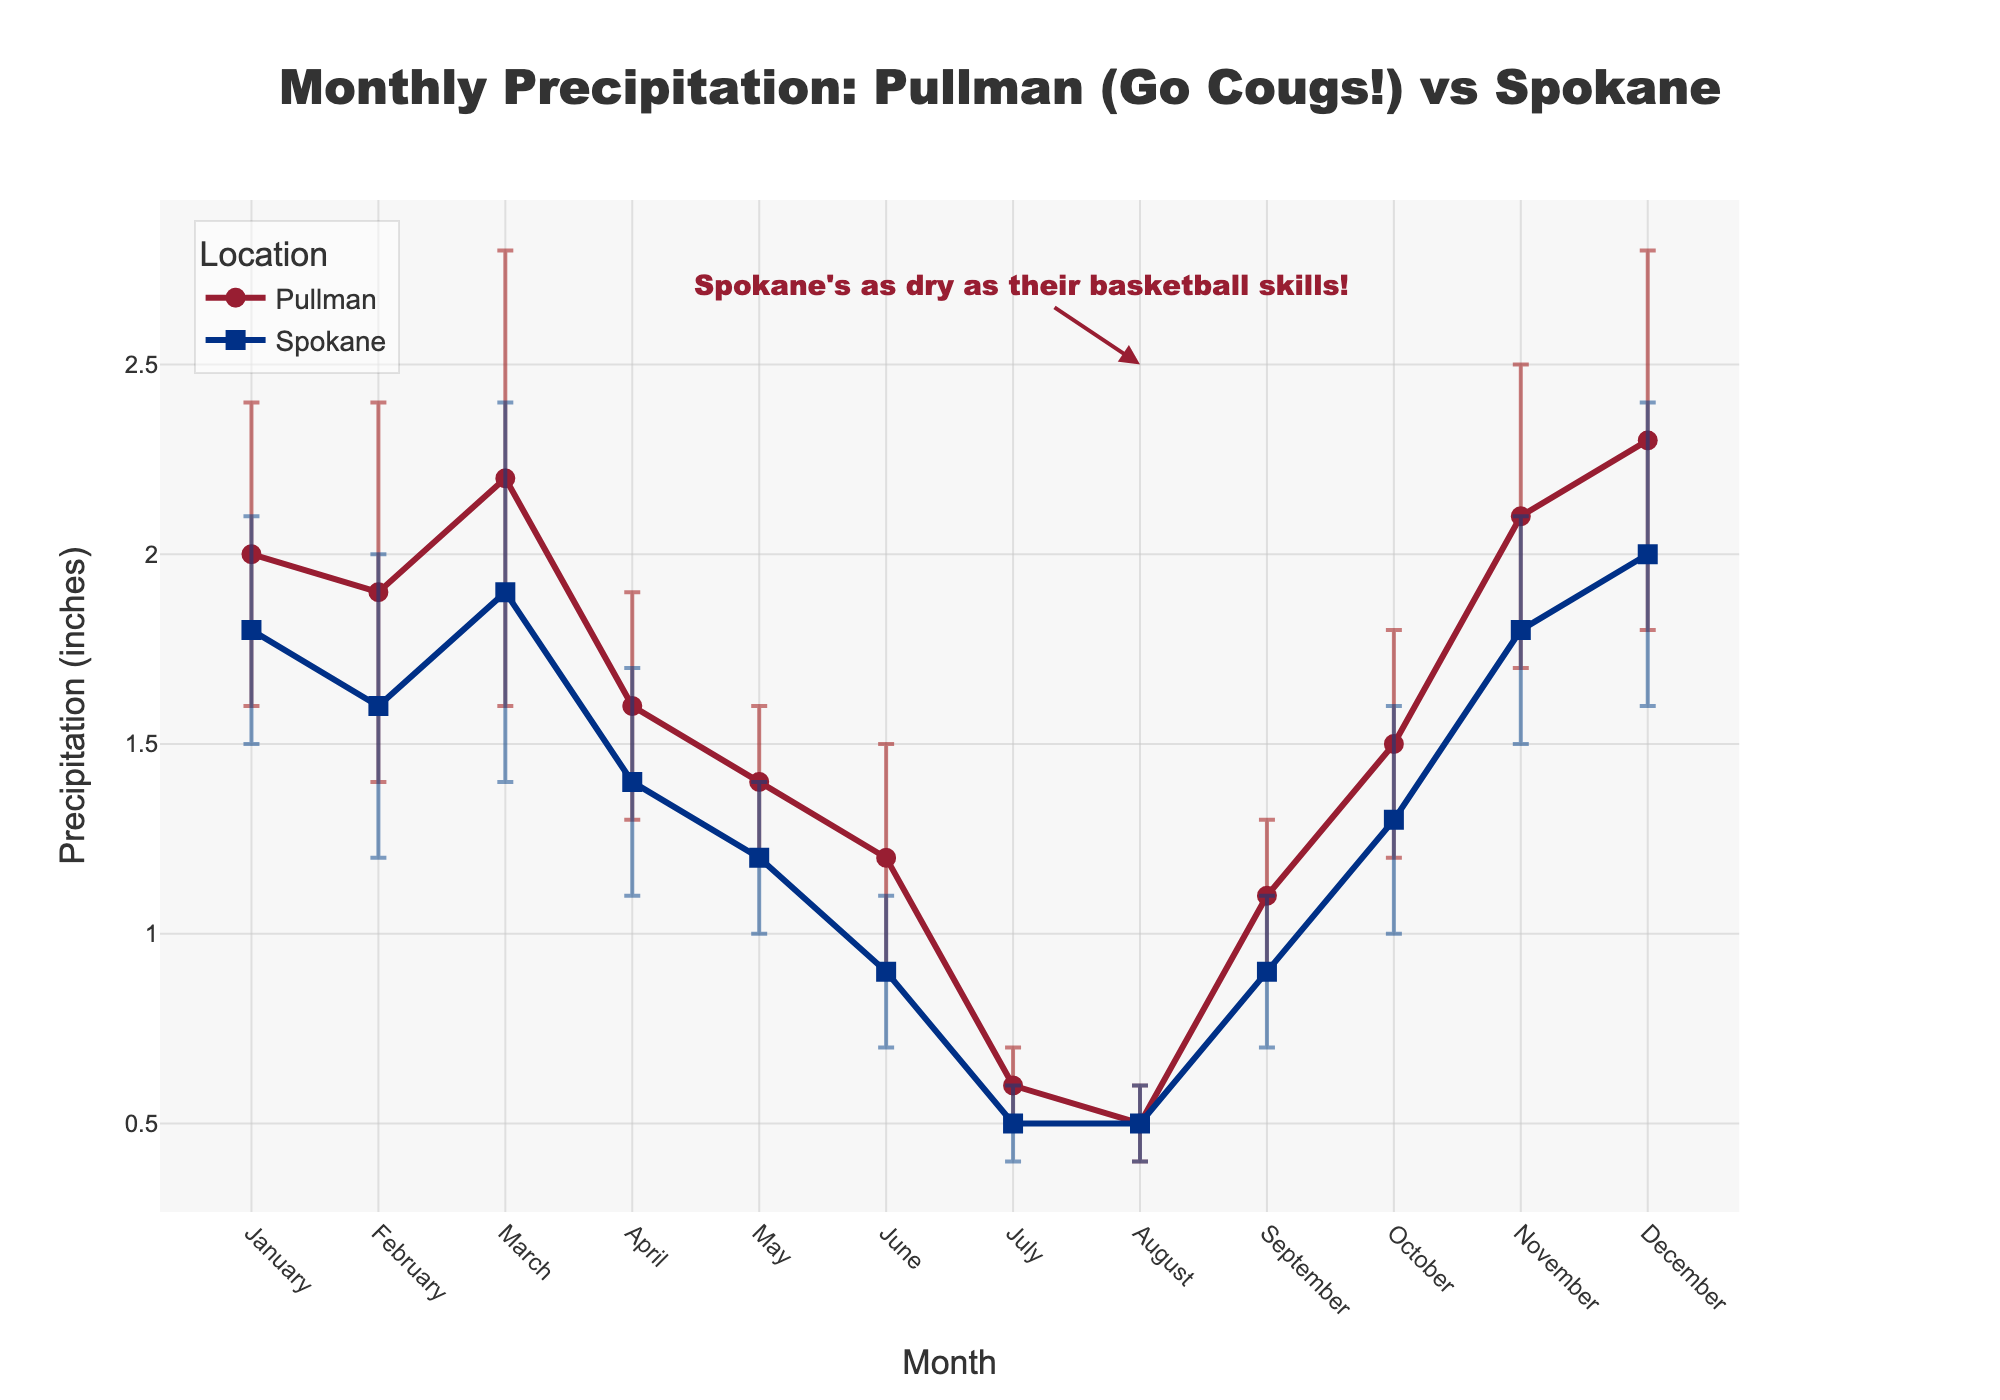Which location has higher average monthly precipitation? To find the average monthly precipitation for each location, sum up the monthly values and then divide by the number of months. The average for Pullman is (2.0 + 1.9 + 2.2 + 1.6 + 1.4 + 1.2 + 0.6 + 0.5 + 1.1 + 1.5 + 2.1 + 2.3) / 12 = 1.58 inches. The average for Spokane is (1.8 + 1.6 + 1.9 + 1.4 + 1.2 + 0.9 + 0.5 + 0.5 + 0.9 + 1.3 + 1.8 + 2.0) / 12 = 1.38 inches. So, Pullman has a higher average monthly precipitation.
Answer: Pullman What month has the lowest precipitation in Pullman? Refer to the precipitation values for each month in Pullman and find the smallest value. The lowest precipitation occurs in August with 0.5 inches.
Answer: August How does the precipitation in September compare between Pullman and Spokane? Look at the precipitation values for September in both locations. Pullman has 1.1 inches of precipitation, while Spokane has 0.9 inches. So, Pullman has higher precipitation in September.
Answer: Pullman Which month has the highest historical variability in precipitation for Pullman? Historical variability is represented by the error bars. Identify the month with the highest error value for Pullman. March has the highest error value of 0.6 inches.
Answer: March How does the precipitation in July compare between Pullman and Spokane? Look at the precipitation values for July in both locations. Pullman has 0.6 inches of precipitation, while Spokane has 0.5 inches. So, Pullman has higher precipitation in July.
Answer: Pullman What is the range of precipitation for Pullman in December considering historical variability? The precipitation in December for Pullman is 2.3 inches with an error of 0.5 inches. This means the range considering historical variability is from 2.3 - 0.5 to 2.3 + 0.5, which is 1.8 to 2.8 inches.
Answer: 1.8 to 2.8 inches Which location has the greater historical variability in January? Compare the error values for January in both locations. Pullman has an error of 0.4 inches, and Spokane has an error of 0.3 inches. Pullman has the greater historical variability.
Answer: Pullman What is the total annual precipitation for Spokane? Sum up the monthly precipitation values for Spokane. The total annual precipitation for Spokane is 1.8 + 1.6 + 1.9 + 1.4 + 1.2 + 0.9 + 0.5 + 0.5 + 0.9 + 1.3 + 1.8 + 2.0 = 15.8 inches.
Answer: 15.8 inches 